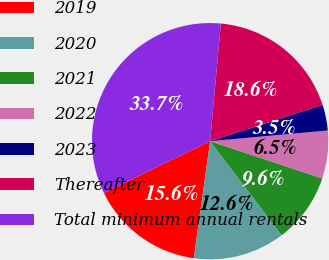<chart> <loc_0><loc_0><loc_500><loc_500><pie_chart><fcel>2019<fcel>2020<fcel>2021<fcel>2022<fcel>2023<fcel>Thereafter<fcel>Total minimum annual rentals<nl><fcel>15.58%<fcel>12.56%<fcel>9.55%<fcel>6.54%<fcel>3.52%<fcel>18.59%<fcel>33.66%<nl></chart> 